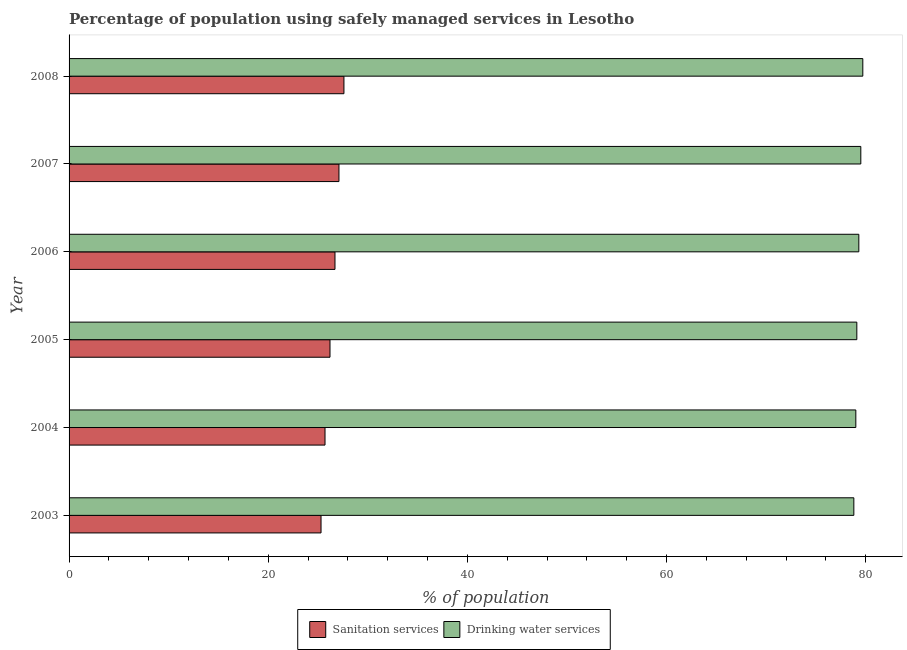How many groups of bars are there?
Offer a very short reply. 6. Are the number of bars per tick equal to the number of legend labels?
Ensure brevity in your answer.  Yes. Are the number of bars on each tick of the Y-axis equal?
Make the answer very short. Yes. How many bars are there on the 6th tick from the bottom?
Your answer should be very brief. 2. What is the label of the 3rd group of bars from the top?
Your answer should be compact. 2006. What is the percentage of population who used sanitation services in 2007?
Your response must be concise. 27.1. Across all years, what is the maximum percentage of population who used sanitation services?
Make the answer very short. 27.6. Across all years, what is the minimum percentage of population who used drinking water services?
Provide a short and direct response. 78.8. In which year was the percentage of population who used sanitation services minimum?
Make the answer very short. 2003. What is the total percentage of population who used sanitation services in the graph?
Offer a terse response. 158.6. What is the difference between the percentage of population who used sanitation services in 2004 and that in 2008?
Your answer should be compact. -1.9. What is the difference between the percentage of population who used drinking water services in 2005 and the percentage of population who used sanitation services in 2007?
Offer a terse response. 52. What is the average percentage of population who used sanitation services per year?
Keep it short and to the point. 26.43. In the year 2008, what is the difference between the percentage of population who used sanitation services and percentage of population who used drinking water services?
Give a very brief answer. -52.1. Is the difference between the percentage of population who used drinking water services in 2004 and 2005 greater than the difference between the percentage of population who used sanitation services in 2004 and 2005?
Your answer should be compact. Yes. What is the difference between the highest and the second highest percentage of population who used sanitation services?
Your answer should be very brief. 0.5. What is the difference between the highest and the lowest percentage of population who used drinking water services?
Ensure brevity in your answer.  0.9. Is the sum of the percentage of population who used sanitation services in 2007 and 2008 greater than the maximum percentage of population who used drinking water services across all years?
Your answer should be compact. No. What does the 1st bar from the top in 2004 represents?
Provide a succinct answer. Drinking water services. What does the 2nd bar from the bottom in 2006 represents?
Your answer should be very brief. Drinking water services. How many bars are there?
Your response must be concise. 12. Are all the bars in the graph horizontal?
Keep it short and to the point. Yes. What is the difference between two consecutive major ticks on the X-axis?
Provide a succinct answer. 20. Are the values on the major ticks of X-axis written in scientific E-notation?
Give a very brief answer. No. Does the graph contain grids?
Your answer should be very brief. No. Where does the legend appear in the graph?
Your response must be concise. Bottom center. How many legend labels are there?
Your answer should be very brief. 2. How are the legend labels stacked?
Provide a succinct answer. Horizontal. What is the title of the graph?
Offer a terse response. Percentage of population using safely managed services in Lesotho. Does "Highest 10% of population" appear as one of the legend labels in the graph?
Offer a terse response. No. What is the label or title of the X-axis?
Provide a succinct answer. % of population. What is the label or title of the Y-axis?
Your response must be concise. Year. What is the % of population in Sanitation services in 2003?
Make the answer very short. 25.3. What is the % of population of Drinking water services in 2003?
Your response must be concise. 78.8. What is the % of population in Sanitation services in 2004?
Ensure brevity in your answer.  25.7. What is the % of population in Drinking water services in 2004?
Keep it short and to the point. 79. What is the % of population of Sanitation services in 2005?
Provide a succinct answer. 26.2. What is the % of population of Drinking water services in 2005?
Your answer should be very brief. 79.1. What is the % of population in Sanitation services in 2006?
Provide a succinct answer. 26.7. What is the % of population of Drinking water services in 2006?
Offer a terse response. 79.3. What is the % of population of Sanitation services in 2007?
Offer a terse response. 27.1. What is the % of population in Drinking water services in 2007?
Give a very brief answer. 79.5. What is the % of population of Sanitation services in 2008?
Your answer should be very brief. 27.6. What is the % of population of Drinking water services in 2008?
Give a very brief answer. 79.7. Across all years, what is the maximum % of population in Sanitation services?
Give a very brief answer. 27.6. Across all years, what is the maximum % of population in Drinking water services?
Your answer should be very brief. 79.7. Across all years, what is the minimum % of population in Sanitation services?
Make the answer very short. 25.3. Across all years, what is the minimum % of population in Drinking water services?
Provide a short and direct response. 78.8. What is the total % of population in Sanitation services in the graph?
Offer a very short reply. 158.6. What is the total % of population in Drinking water services in the graph?
Your response must be concise. 475.4. What is the difference between the % of population in Sanitation services in 2003 and that in 2005?
Offer a very short reply. -0.9. What is the difference between the % of population of Drinking water services in 2003 and that in 2005?
Keep it short and to the point. -0.3. What is the difference between the % of population of Sanitation services in 2003 and that in 2006?
Offer a terse response. -1.4. What is the difference between the % of population of Drinking water services in 2003 and that in 2006?
Provide a short and direct response. -0.5. What is the difference between the % of population in Drinking water services in 2003 and that in 2007?
Your answer should be very brief. -0.7. What is the difference between the % of population of Sanitation services in 2003 and that in 2008?
Provide a short and direct response. -2.3. What is the difference between the % of population in Drinking water services in 2004 and that in 2005?
Ensure brevity in your answer.  -0.1. What is the difference between the % of population in Sanitation services in 2004 and that in 2006?
Provide a succinct answer. -1. What is the difference between the % of population in Drinking water services in 2004 and that in 2006?
Your response must be concise. -0.3. What is the difference between the % of population of Drinking water services in 2004 and that in 2008?
Provide a succinct answer. -0.7. What is the difference between the % of population of Sanitation services in 2005 and that in 2006?
Your response must be concise. -0.5. What is the difference between the % of population of Sanitation services in 2005 and that in 2008?
Provide a succinct answer. -1.4. What is the difference between the % of population in Drinking water services in 2005 and that in 2008?
Offer a very short reply. -0.6. What is the difference between the % of population of Sanitation services in 2006 and that in 2007?
Your answer should be compact. -0.4. What is the difference between the % of population of Drinking water services in 2006 and that in 2007?
Provide a succinct answer. -0.2. What is the difference between the % of population of Sanitation services in 2006 and that in 2008?
Make the answer very short. -0.9. What is the difference between the % of population in Sanitation services in 2007 and that in 2008?
Offer a very short reply. -0.5. What is the difference between the % of population of Sanitation services in 2003 and the % of population of Drinking water services in 2004?
Your answer should be very brief. -53.7. What is the difference between the % of population in Sanitation services in 2003 and the % of population in Drinking water services in 2005?
Provide a short and direct response. -53.8. What is the difference between the % of population in Sanitation services in 2003 and the % of population in Drinking water services in 2006?
Your answer should be compact. -54. What is the difference between the % of population in Sanitation services in 2003 and the % of population in Drinking water services in 2007?
Offer a very short reply. -54.2. What is the difference between the % of population in Sanitation services in 2003 and the % of population in Drinking water services in 2008?
Offer a terse response. -54.4. What is the difference between the % of population of Sanitation services in 2004 and the % of population of Drinking water services in 2005?
Offer a very short reply. -53.4. What is the difference between the % of population in Sanitation services in 2004 and the % of population in Drinking water services in 2006?
Give a very brief answer. -53.6. What is the difference between the % of population in Sanitation services in 2004 and the % of population in Drinking water services in 2007?
Offer a terse response. -53.8. What is the difference between the % of population in Sanitation services in 2004 and the % of population in Drinking water services in 2008?
Give a very brief answer. -54. What is the difference between the % of population in Sanitation services in 2005 and the % of population in Drinking water services in 2006?
Offer a very short reply. -53.1. What is the difference between the % of population in Sanitation services in 2005 and the % of population in Drinking water services in 2007?
Your response must be concise. -53.3. What is the difference between the % of population in Sanitation services in 2005 and the % of population in Drinking water services in 2008?
Offer a very short reply. -53.5. What is the difference between the % of population of Sanitation services in 2006 and the % of population of Drinking water services in 2007?
Offer a very short reply. -52.8. What is the difference between the % of population in Sanitation services in 2006 and the % of population in Drinking water services in 2008?
Provide a succinct answer. -53. What is the difference between the % of population of Sanitation services in 2007 and the % of population of Drinking water services in 2008?
Provide a succinct answer. -52.6. What is the average % of population in Sanitation services per year?
Your answer should be compact. 26.43. What is the average % of population in Drinking water services per year?
Offer a terse response. 79.23. In the year 2003, what is the difference between the % of population of Sanitation services and % of population of Drinking water services?
Offer a very short reply. -53.5. In the year 2004, what is the difference between the % of population in Sanitation services and % of population in Drinking water services?
Offer a terse response. -53.3. In the year 2005, what is the difference between the % of population of Sanitation services and % of population of Drinking water services?
Make the answer very short. -52.9. In the year 2006, what is the difference between the % of population of Sanitation services and % of population of Drinking water services?
Your response must be concise. -52.6. In the year 2007, what is the difference between the % of population of Sanitation services and % of population of Drinking water services?
Offer a very short reply. -52.4. In the year 2008, what is the difference between the % of population in Sanitation services and % of population in Drinking water services?
Make the answer very short. -52.1. What is the ratio of the % of population of Sanitation services in 2003 to that in 2004?
Ensure brevity in your answer.  0.98. What is the ratio of the % of population of Sanitation services in 2003 to that in 2005?
Offer a very short reply. 0.97. What is the ratio of the % of population in Sanitation services in 2003 to that in 2006?
Ensure brevity in your answer.  0.95. What is the ratio of the % of population in Drinking water services in 2003 to that in 2006?
Offer a terse response. 0.99. What is the ratio of the % of population of Sanitation services in 2003 to that in 2007?
Offer a terse response. 0.93. What is the ratio of the % of population in Drinking water services in 2003 to that in 2007?
Provide a short and direct response. 0.99. What is the ratio of the % of population in Drinking water services in 2003 to that in 2008?
Offer a terse response. 0.99. What is the ratio of the % of population of Sanitation services in 2004 to that in 2005?
Give a very brief answer. 0.98. What is the ratio of the % of population in Drinking water services in 2004 to that in 2005?
Ensure brevity in your answer.  1. What is the ratio of the % of population of Sanitation services in 2004 to that in 2006?
Your answer should be very brief. 0.96. What is the ratio of the % of population in Drinking water services in 2004 to that in 2006?
Make the answer very short. 1. What is the ratio of the % of population of Sanitation services in 2004 to that in 2007?
Provide a succinct answer. 0.95. What is the ratio of the % of population of Sanitation services in 2004 to that in 2008?
Make the answer very short. 0.93. What is the ratio of the % of population in Drinking water services in 2004 to that in 2008?
Offer a terse response. 0.99. What is the ratio of the % of population in Sanitation services in 2005 to that in 2006?
Make the answer very short. 0.98. What is the ratio of the % of population in Drinking water services in 2005 to that in 2006?
Give a very brief answer. 1. What is the ratio of the % of population of Sanitation services in 2005 to that in 2007?
Provide a short and direct response. 0.97. What is the ratio of the % of population in Drinking water services in 2005 to that in 2007?
Provide a short and direct response. 0.99. What is the ratio of the % of population of Sanitation services in 2005 to that in 2008?
Provide a short and direct response. 0.95. What is the ratio of the % of population of Sanitation services in 2006 to that in 2007?
Provide a succinct answer. 0.99. What is the ratio of the % of population of Drinking water services in 2006 to that in 2007?
Provide a short and direct response. 1. What is the ratio of the % of population in Sanitation services in 2006 to that in 2008?
Offer a terse response. 0.97. What is the ratio of the % of population in Drinking water services in 2006 to that in 2008?
Give a very brief answer. 0.99. What is the ratio of the % of population of Sanitation services in 2007 to that in 2008?
Make the answer very short. 0.98. What is the ratio of the % of population in Drinking water services in 2007 to that in 2008?
Offer a terse response. 1. 